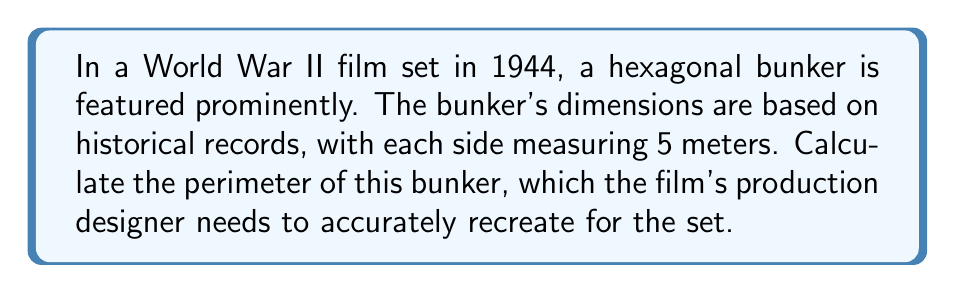Can you solve this math problem? To find the perimeter of a regular hexagonal bunker, we need to:

1. Identify the given information:
   - The bunker is a regular hexagon (all sides equal)
   - Each side measures 5 meters

2. Recall the formula for the perimeter of a regular polygon:
   $$P = ns$$
   where $P$ is the perimeter, $n$ is the number of sides, and $s$ is the length of each side.

3. For a hexagon, $n = 6$

4. Substitute the values into the formula:
   $$P = 6 \times 5$$

5. Perform the calculation:
   $$P = 30$$

Therefore, the perimeter of the hexagonal bunker is 30 meters.
Answer: 30 meters 